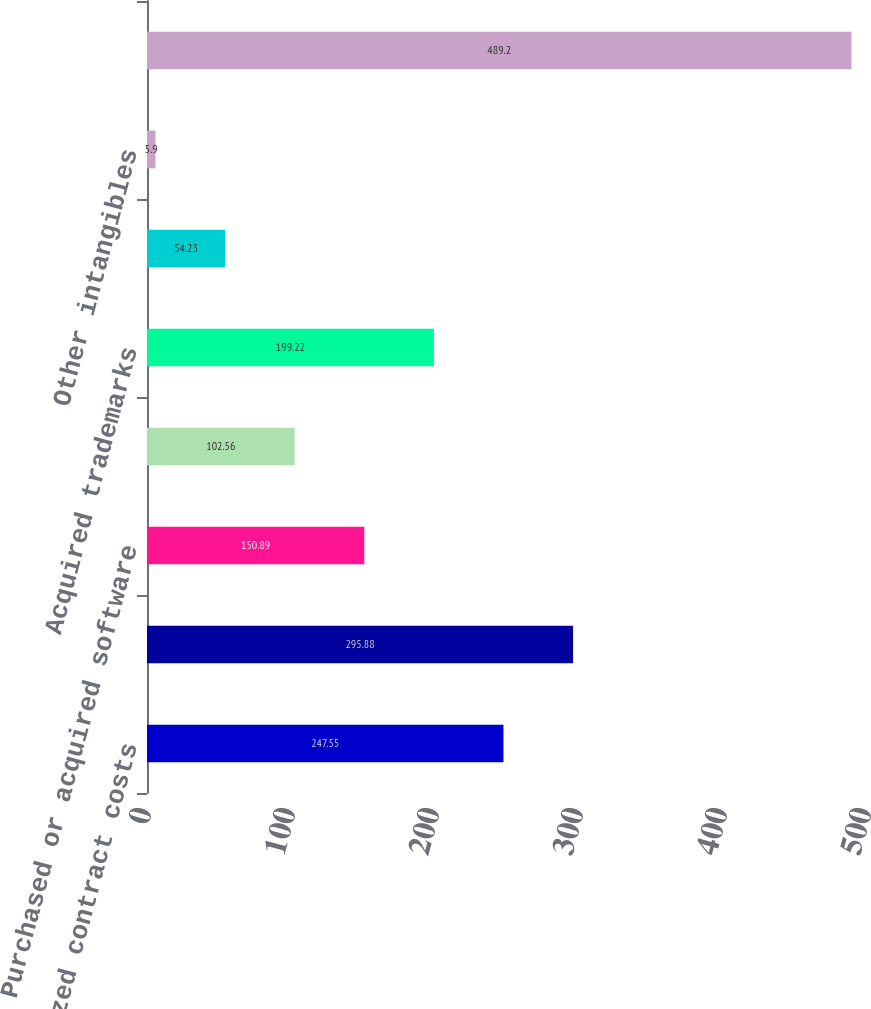Convert chart to OTSL. <chart><loc_0><loc_0><loc_500><loc_500><bar_chart><fcel>Capitalized contract costs<fcel>Acquired contracts<fcel>Purchased or acquired software<fcel>Developed software<fcel>Acquired trademarks<fcel>Projects in process<fcel>Other intangibles<fcel>Total other intangible assets<nl><fcel>247.55<fcel>295.88<fcel>150.89<fcel>102.56<fcel>199.22<fcel>54.23<fcel>5.9<fcel>489.2<nl></chart> 